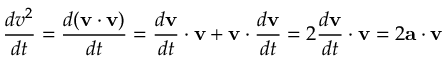Convert formula to latex. <formula><loc_0><loc_0><loc_500><loc_500>{ \frac { d v ^ { 2 } } { d t } } = { \frac { d ( v \cdot v ) } { d t } } = { \frac { d v } { d t } } \cdot v + v \cdot { \frac { d v } { d t } } = 2 { \frac { d v } { d t } } \cdot v = 2 a \cdot v</formula> 